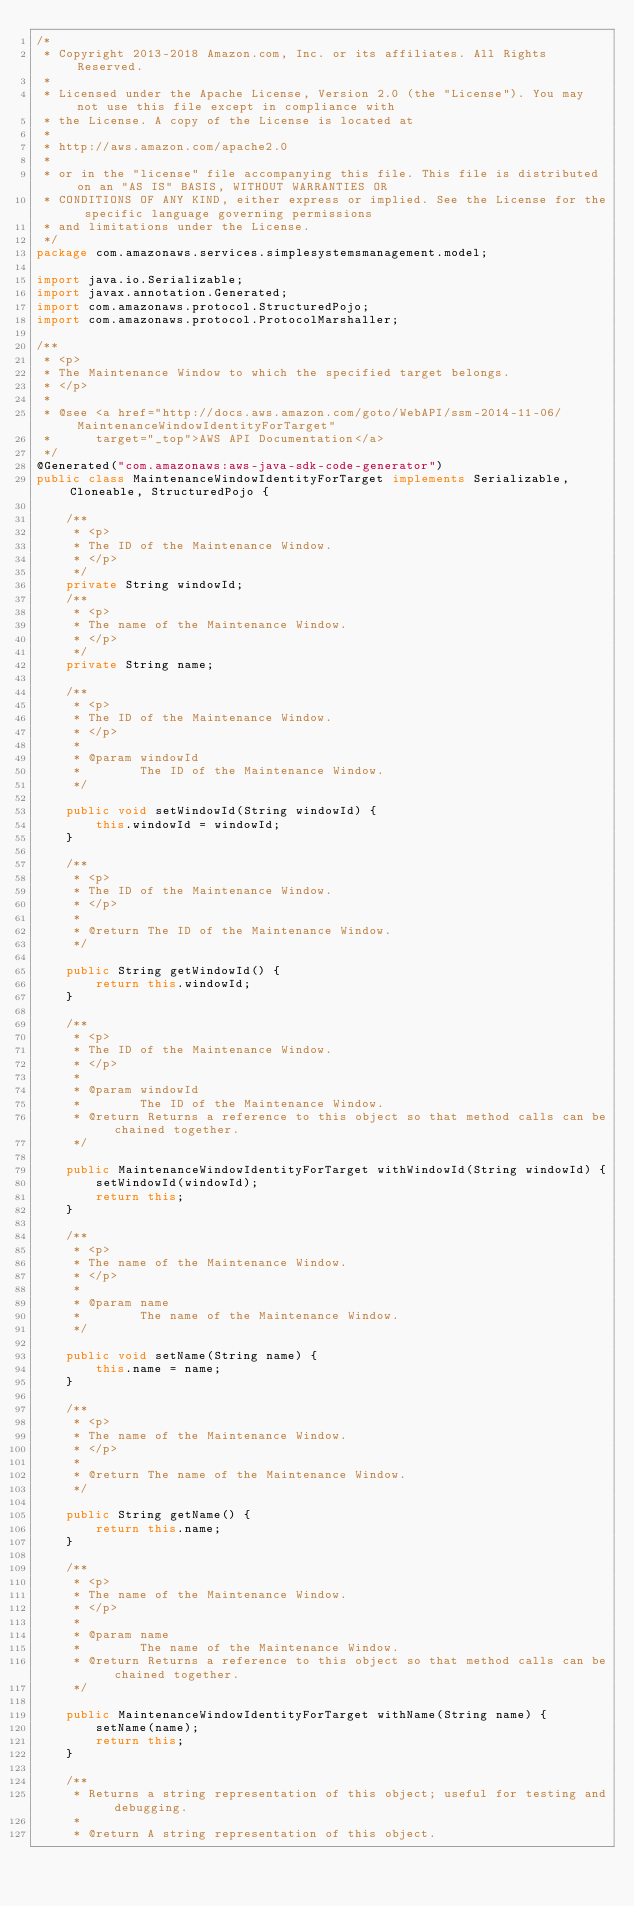<code> <loc_0><loc_0><loc_500><loc_500><_Java_>/*
 * Copyright 2013-2018 Amazon.com, Inc. or its affiliates. All Rights Reserved.
 * 
 * Licensed under the Apache License, Version 2.0 (the "License"). You may not use this file except in compliance with
 * the License. A copy of the License is located at
 * 
 * http://aws.amazon.com/apache2.0
 * 
 * or in the "license" file accompanying this file. This file is distributed on an "AS IS" BASIS, WITHOUT WARRANTIES OR
 * CONDITIONS OF ANY KIND, either express or implied. See the License for the specific language governing permissions
 * and limitations under the License.
 */
package com.amazonaws.services.simplesystemsmanagement.model;

import java.io.Serializable;
import javax.annotation.Generated;
import com.amazonaws.protocol.StructuredPojo;
import com.amazonaws.protocol.ProtocolMarshaller;

/**
 * <p>
 * The Maintenance Window to which the specified target belongs.
 * </p>
 * 
 * @see <a href="http://docs.aws.amazon.com/goto/WebAPI/ssm-2014-11-06/MaintenanceWindowIdentityForTarget"
 *      target="_top">AWS API Documentation</a>
 */
@Generated("com.amazonaws:aws-java-sdk-code-generator")
public class MaintenanceWindowIdentityForTarget implements Serializable, Cloneable, StructuredPojo {

    /**
     * <p>
     * The ID of the Maintenance Window.
     * </p>
     */
    private String windowId;
    /**
     * <p>
     * The name of the Maintenance Window.
     * </p>
     */
    private String name;

    /**
     * <p>
     * The ID of the Maintenance Window.
     * </p>
     * 
     * @param windowId
     *        The ID of the Maintenance Window.
     */

    public void setWindowId(String windowId) {
        this.windowId = windowId;
    }

    /**
     * <p>
     * The ID of the Maintenance Window.
     * </p>
     * 
     * @return The ID of the Maintenance Window.
     */

    public String getWindowId() {
        return this.windowId;
    }

    /**
     * <p>
     * The ID of the Maintenance Window.
     * </p>
     * 
     * @param windowId
     *        The ID of the Maintenance Window.
     * @return Returns a reference to this object so that method calls can be chained together.
     */

    public MaintenanceWindowIdentityForTarget withWindowId(String windowId) {
        setWindowId(windowId);
        return this;
    }

    /**
     * <p>
     * The name of the Maintenance Window.
     * </p>
     * 
     * @param name
     *        The name of the Maintenance Window.
     */

    public void setName(String name) {
        this.name = name;
    }

    /**
     * <p>
     * The name of the Maintenance Window.
     * </p>
     * 
     * @return The name of the Maintenance Window.
     */

    public String getName() {
        return this.name;
    }

    /**
     * <p>
     * The name of the Maintenance Window.
     * </p>
     * 
     * @param name
     *        The name of the Maintenance Window.
     * @return Returns a reference to this object so that method calls can be chained together.
     */

    public MaintenanceWindowIdentityForTarget withName(String name) {
        setName(name);
        return this;
    }

    /**
     * Returns a string representation of this object; useful for testing and debugging.
     *
     * @return A string representation of this object.</code> 